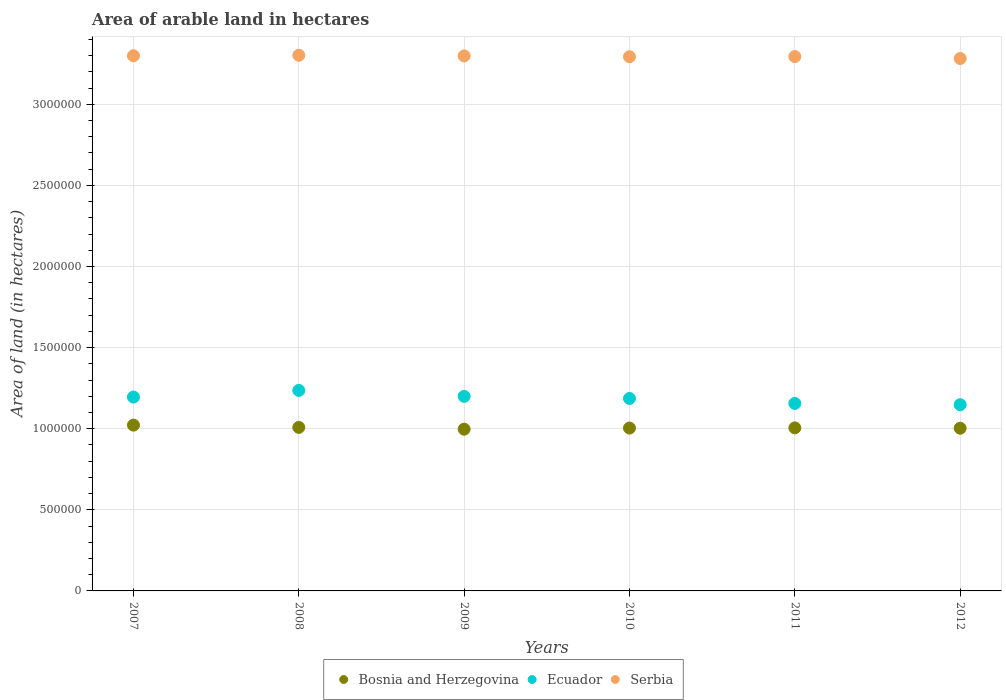What is the total arable land in Bosnia and Herzegovina in 2012?
Keep it short and to the point. 1.00e+06. Across all years, what is the maximum total arable land in Ecuador?
Provide a succinct answer. 1.24e+06. Across all years, what is the minimum total arable land in Bosnia and Herzegovina?
Provide a succinct answer. 9.97e+05. What is the total total arable land in Serbia in the graph?
Your answer should be very brief. 1.98e+07. What is the difference between the total arable land in Serbia in 2009 and that in 2011?
Offer a very short reply. 4000. What is the difference between the total arable land in Serbia in 2010 and the total arable land in Ecuador in 2008?
Give a very brief answer. 2.06e+06. What is the average total arable land in Serbia per year?
Offer a very short reply. 3.29e+06. In the year 2011, what is the difference between the total arable land in Ecuador and total arable land in Serbia?
Give a very brief answer. -2.14e+06. What is the ratio of the total arable land in Ecuador in 2008 to that in 2011?
Your response must be concise. 1.07. Is the difference between the total arable land in Ecuador in 2007 and 2012 greater than the difference between the total arable land in Serbia in 2007 and 2012?
Provide a short and direct response. Yes. What is the difference between the highest and the second highest total arable land in Bosnia and Herzegovina?
Provide a succinct answer. 1.40e+04. Is it the case that in every year, the sum of the total arable land in Ecuador and total arable land in Serbia  is greater than the total arable land in Bosnia and Herzegovina?
Offer a terse response. Yes. Is the total arable land in Ecuador strictly greater than the total arable land in Bosnia and Herzegovina over the years?
Make the answer very short. Yes. Is the total arable land in Serbia strictly less than the total arable land in Bosnia and Herzegovina over the years?
Your answer should be compact. No. How many dotlines are there?
Ensure brevity in your answer.  3. Where does the legend appear in the graph?
Offer a very short reply. Bottom center. How are the legend labels stacked?
Provide a short and direct response. Horizontal. What is the title of the graph?
Give a very brief answer. Area of arable land in hectares. Does "Cyprus" appear as one of the legend labels in the graph?
Provide a succinct answer. No. What is the label or title of the X-axis?
Offer a very short reply. Years. What is the label or title of the Y-axis?
Ensure brevity in your answer.  Area of land (in hectares). What is the Area of land (in hectares) in Bosnia and Herzegovina in 2007?
Your response must be concise. 1.02e+06. What is the Area of land (in hectares) of Ecuador in 2007?
Give a very brief answer. 1.20e+06. What is the Area of land (in hectares) of Serbia in 2007?
Provide a short and direct response. 3.30e+06. What is the Area of land (in hectares) in Bosnia and Herzegovina in 2008?
Offer a terse response. 1.01e+06. What is the Area of land (in hectares) of Ecuador in 2008?
Your response must be concise. 1.24e+06. What is the Area of land (in hectares) of Serbia in 2008?
Your answer should be very brief. 3.30e+06. What is the Area of land (in hectares) of Bosnia and Herzegovina in 2009?
Your answer should be compact. 9.97e+05. What is the Area of land (in hectares) in Ecuador in 2009?
Your answer should be compact. 1.20e+06. What is the Area of land (in hectares) of Serbia in 2009?
Keep it short and to the point. 3.30e+06. What is the Area of land (in hectares) of Bosnia and Herzegovina in 2010?
Provide a succinct answer. 1.00e+06. What is the Area of land (in hectares) of Ecuador in 2010?
Your answer should be very brief. 1.19e+06. What is the Area of land (in hectares) of Serbia in 2010?
Provide a short and direct response. 3.29e+06. What is the Area of land (in hectares) in Bosnia and Herzegovina in 2011?
Provide a short and direct response. 1.00e+06. What is the Area of land (in hectares) of Ecuador in 2011?
Offer a terse response. 1.16e+06. What is the Area of land (in hectares) in Serbia in 2011?
Give a very brief answer. 3.29e+06. What is the Area of land (in hectares) in Bosnia and Herzegovina in 2012?
Give a very brief answer. 1.00e+06. What is the Area of land (in hectares) in Ecuador in 2012?
Offer a very short reply. 1.15e+06. What is the Area of land (in hectares) in Serbia in 2012?
Offer a very short reply. 3.28e+06. Across all years, what is the maximum Area of land (in hectares) in Bosnia and Herzegovina?
Give a very brief answer. 1.02e+06. Across all years, what is the maximum Area of land (in hectares) in Ecuador?
Offer a terse response. 1.24e+06. Across all years, what is the maximum Area of land (in hectares) in Serbia?
Provide a succinct answer. 3.30e+06. Across all years, what is the minimum Area of land (in hectares) in Bosnia and Herzegovina?
Ensure brevity in your answer.  9.97e+05. Across all years, what is the minimum Area of land (in hectares) in Ecuador?
Offer a terse response. 1.15e+06. Across all years, what is the minimum Area of land (in hectares) in Serbia?
Your response must be concise. 3.28e+06. What is the total Area of land (in hectares) in Bosnia and Herzegovina in the graph?
Ensure brevity in your answer.  6.04e+06. What is the total Area of land (in hectares) of Ecuador in the graph?
Provide a succinct answer. 7.12e+06. What is the total Area of land (in hectares) in Serbia in the graph?
Your response must be concise. 1.98e+07. What is the difference between the Area of land (in hectares) in Bosnia and Herzegovina in 2007 and that in 2008?
Offer a very short reply. 1.40e+04. What is the difference between the Area of land (in hectares) of Ecuador in 2007 and that in 2008?
Offer a very short reply. -4.10e+04. What is the difference between the Area of land (in hectares) in Serbia in 2007 and that in 2008?
Offer a very short reply. -3000. What is the difference between the Area of land (in hectares) of Bosnia and Herzegovina in 2007 and that in 2009?
Offer a terse response. 2.50e+04. What is the difference between the Area of land (in hectares) of Ecuador in 2007 and that in 2009?
Your answer should be very brief. -4400. What is the difference between the Area of land (in hectares) of Serbia in 2007 and that in 2009?
Your response must be concise. 1000. What is the difference between the Area of land (in hectares) of Bosnia and Herzegovina in 2007 and that in 2010?
Your response must be concise. 1.80e+04. What is the difference between the Area of land (in hectares) of Ecuador in 2007 and that in 2010?
Your answer should be very brief. 8600. What is the difference between the Area of land (in hectares) in Serbia in 2007 and that in 2010?
Give a very brief answer. 6000. What is the difference between the Area of land (in hectares) of Bosnia and Herzegovina in 2007 and that in 2011?
Ensure brevity in your answer.  1.70e+04. What is the difference between the Area of land (in hectares) in Ecuador in 2007 and that in 2011?
Offer a very short reply. 3.93e+04. What is the difference between the Area of land (in hectares) of Bosnia and Herzegovina in 2007 and that in 2012?
Your response must be concise. 1.90e+04. What is the difference between the Area of land (in hectares) of Ecuador in 2007 and that in 2012?
Ensure brevity in your answer.  4.71e+04. What is the difference between the Area of land (in hectares) of Serbia in 2007 and that in 2012?
Provide a short and direct response. 1.70e+04. What is the difference between the Area of land (in hectares) of Bosnia and Herzegovina in 2008 and that in 2009?
Offer a terse response. 1.10e+04. What is the difference between the Area of land (in hectares) in Ecuador in 2008 and that in 2009?
Your answer should be very brief. 3.66e+04. What is the difference between the Area of land (in hectares) of Serbia in 2008 and that in 2009?
Offer a very short reply. 4000. What is the difference between the Area of land (in hectares) in Bosnia and Herzegovina in 2008 and that in 2010?
Your answer should be compact. 4000. What is the difference between the Area of land (in hectares) in Ecuador in 2008 and that in 2010?
Offer a very short reply. 4.96e+04. What is the difference between the Area of land (in hectares) of Serbia in 2008 and that in 2010?
Keep it short and to the point. 9000. What is the difference between the Area of land (in hectares) in Bosnia and Herzegovina in 2008 and that in 2011?
Provide a succinct answer. 3000. What is the difference between the Area of land (in hectares) in Ecuador in 2008 and that in 2011?
Offer a terse response. 8.03e+04. What is the difference between the Area of land (in hectares) in Serbia in 2008 and that in 2011?
Provide a succinct answer. 8000. What is the difference between the Area of land (in hectares) of Bosnia and Herzegovina in 2008 and that in 2012?
Your response must be concise. 5000. What is the difference between the Area of land (in hectares) in Ecuador in 2008 and that in 2012?
Keep it short and to the point. 8.81e+04. What is the difference between the Area of land (in hectares) of Bosnia and Herzegovina in 2009 and that in 2010?
Your response must be concise. -7000. What is the difference between the Area of land (in hectares) in Ecuador in 2009 and that in 2010?
Your response must be concise. 1.30e+04. What is the difference between the Area of land (in hectares) in Bosnia and Herzegovina in 2009 and that in 2011?
Make the answer very short. -8000. What is the difference between the Area of land (in hectares) of Ecuador in 2009 and that in 2011?
Make the answer very short. 4.37e+04. What is the difference between the Area of land (in hectares) of Serbia in 2009 and that in 2011?
Provide a succinct answer. 4000. What is the difference between the Area of land (in hectares) of Bosnia and Herzegovina in 2009 and that in 2012?
Give a very brief answer. -6000. What is the difference between the Area of land (in hectares) of Ecuador in 2009 and that in 2012?
Offer a very short reply. 5.15e+04. What is the difference between the Area of land (in hectares) in Serbia in 2009 and that in 2012?
Keep it short and to the point. 1.60e+04. What is the difference between the Area of land (in hectares) in Bosnia and Herzegovina in 2010 and that in 2011?
Provide a short and direct response. -1000. What is the difference between the Area of land (in hectares) of Ecuador in 2010 and that in 2011?
Your answer should be very brief. 3.07e+04. What is the difference between the Area of land (in hectares) of Serbia in 2010 and that in 2011?
Your answer should be compact. -1000. What is the difference between the Area of land (in hectares) of Bosnia and Herzegovina in 2010 and that in 2012?
Your answer should be compact. 1000. What is the difference between the Area of land (in hectares) of Ecuador in 2010 and that in 2012?
Ensure brevity in your answer.  3.85e+04. What is the difference between the Area of land (in hectares) in Serbia in 2010 and that in 2012?
Provide a succinct answer. 1.10e+04. What is the difference between the Area of land (in hectares) of Bosnia and Herzegovina in 2011 and that in 2012?
Keep it short and to the point. 2000. What is the difference between the Area of land (in hectares) of Ecuador in 2011 and that in 2012?
Keep it short and to the point. 7800. What is the difference between the Area of land (in hectares) of Serbia in 2011 and that in 2012?
Make the answer very short. 1.20e+04. What is the difference between the Area of land (in hectares) in Bosnia and Herzegovina in 2007 and the Area of land (in hectares) in Ecuador in 2008?
Ensure brevity in your answer.  -2.14e+05. What is the difference between the Area of land (in hectares) of Bosnia and Herzegovina in 2007 and the Area of land (in hectares) of Serbia in 2008?
Your answer should be compact. -2.28e+06. What is the difference between the Area of land (in hectares) in Ecuador in 2007 and the Area of land (in hectares) in Serbia in 2008?
Your answer should be compact. -2.11e+06. What is the difference between the Area of land (in hectares) of Bosnia and Herzegovina in 2007 and the Area of land (in hectares) of Ecuador in 2009?
Offer a very short reply. -1.77e+05. What is the difference between the Area of land (in hectares) of Bosnia and Herzegovina in 2007 and the Area of land (in hectares) of Serbia in 2009?
Your answer should be compact. -2.28e+06. What is the difference between the Area of land (in hectares) of Ecuador in 2007 and the Area of land (in hectares) of Serbia in 2009?
Offer a terse response. -2.10e+06. What is the difference between the Area of land (in hectares) of Bosnia and Herzegovina in 2007 and the Area of land (in hectares) of Ecuador in 2010?
Offer a very short reply. -1.64e+05. What is the difference between the Area of land (in hectares) in Bosnia and Herzegovina in 2007 and the Area of land (in hectares) in Serbia in 2010?
Your answer should be compact. -2.27e+06. What is the difference between the Area of land (in hectares) of Ecuador in 2007 and the Area of land (in hectares) of Serbia in 2010?
Your answer should be very brief. -2.10e+06. What is the difference between the Area of land (in hectares) of Bosnia and Herzegovina in 2007 and the Area of land (in hectares) of Ecuador in 2011?
Give a very brief answer. -1.34e+05. What is the difference between the Area of land (in hectares) in Bosnia and Herzegovina in 2007 and the Area of land (in hectares) in Serbia in 2011?
Provide a short and direct response. -2.27e+06. What is the difference between the Area of land (in hectares) in Ecuador in 2007 and the Area of land (in hectares) in Serbia in 2011?
Give a very brief answer. -2.10e+06. What is the difference between the Area of land (in hectares) of Bosnia and Herzegovina in 2007 and the Area of land (in hectares) of Ecuador in 2012?
Your answer should be very brief. -1.26e+05. What is the difference between the Area of land (in hectares) of Bosnia and Herzegovina in 2007 and the Area of land (in hectares) of Serbia in 2012?
Make the answer very short. -2.26e+06. What is the difference between the Area of land (in hectares) of Ecuador in 2007 and the Area of land (in hectares) of Serbia in 2012?
Offer a terse response. -2.09e+06. What is the difference between the Area of land (in hectares) in Bosnia and Herzegovina in 2008 and the Area of land (in hectares) in Ecuador in 2009?
Make the answer very short. -1.91e+05. What is the difference between the Area of land (in hectares) of Bosnia and Herzegovina in 2008 and the Area of land (in hectares) of Serbia in 2009?
Give a very brief answer. -2.29e+06. What is the difference between the Area of land (in hectares) of Ecuador in 2008 and the Area of land (in hectares) of Serbia in 2009?
Offer a terse response. -2.06e+06. What is the difference between the Area of land (in hectares) of Bosnia and Herzegovina in 2008 and the Area of land (in hectares) of Ecuador in 2010?
Your response must be concise. -1.78e+05. What is the difference between the Area of land (in hectares) in Bosnia and Herzegovina in 2008 and the Area of land (in hectares) in Serbia in 2010?
Provide a succinct answer. -2.28e+06. What is the difference between the Area of land (in hectares) of Ecuador in 2008 and the Area of land (in hectares) of Serbia in 2010?
Your answer should be very brief. -2.06e+06. What is the difference between the Area of land (in hectares) in Bosnia and Herzegovina in 2008 and the Area of land (in hectares) in Ecuador in 2011?
Keep it short and to the point. -1.48e+05. What is the difference between the Area of land (in hectares) of Bosnia and Herzegovina in 2008 and the Area of land (in hectares) of Serbia in 2011?
Your answer should be compact. -2.29e+06. What is the difference between the Area of land (in hectares) of Ecuador in 2008 and the Area of land (in hectares) of Serbia in 2011?
Your response must be concise. -2.06e+06. What is the difference between the Area of land (in hectares) of Bosnia and Herzegovina in 2008 and the Area of land (in hectares) of Ecuador in 2012?
Give a very brief answer. -1.40e+05. What is the difference between the Area of land (in hectares) in Bosnia and Herzegovina in 2008 and the Area of land (in hectares) in Serbia in 2012?
Your response must be concise. -2.27e+06. What is the difference between the Area of land (in hectares) of Ecuador in 2008 and the Area of land (in hectares) of Serbia in 2012?
Make the answer very short. -2.05e+06. What is the difference between the Area of land (in hectares) in Bosnia and Herzegovina in 2009 and the Area of land (in hectares) in Ecuador in 2010?
Your answer should be compact. -1.89e+05. What is the difference between the Area of land (in hectares) in Bosnia and Herzegovina in 2009 and the Area of land (in hectares) in Serbia in 2010?
Your response must be concise. -2.30e+06. What is the difference between the Area of land (in hectares) in Ecuador in 2009 and the Area of land (in hectares) in Serbia in 2010?
Keep it short and to the point. -2.09e+06. What is the difference between the Area of land (in hectares) of Bosnia and Herzegovina in 2009 and the Area of land (in hectares) of Ecuador in 2011?
Give a very brief answer. -1.59e+05. What is the difference between the Area of land (in hectares) in Bosnia and Herzegovina in 2009 and the Area of land (in hectares) in Serbia in 2011?
Ensure brevity in your answer.  -2.30e+06. What is the difference between the Area of land (in hectares) in Ecuador in 2009 and the Area of land (in hectares) in Serbia in 2011?
Offer a terse response. -2.09e+06. What is the difference between the Area of land (in hectares) of Bosnia and Herzegovina in 2009 and the Area of land (in hectares) of Ecuador in 2012?
Your response must be concise. -1.51e+05. What is the difference between the Area of land (in hectares) of Bosnia and Herzegovina in 2009 and the Area of land (in hectares) of Serbia in 2012?
Your response must be concise. -2.28e+06. What is the difference between the Area of land (in hectares) in Ecuador in 2009 and the Area of land (in hectares) in Serbia in 2012?
Provide a short and direct response. -2.08e+06. What is the difference between the Area of land (in hectares) of Bosnia and Herzegovina in 2010 and the Area of land (in hectares) of Ecuador in 2011?
Give a very brief answer. -1.52e+05. What is the difference between the Area of land (in hectares) of Bosnia and Herzegovina in 2010 and the Area of land (in hectares) of Serbia in 2011?
Offer a very short reply. -2.29e+06. What is the difference between the Area of land (in hectares) of Ecuador in 2010 and the Area of land (in hectares) of Serbia in 2011?
Your answer should be very brief. -2.11e+06. What is the difference between the Area of land (in hectares) of Bosnia and Herzegovina in 2010 and the Area of land (in hectares) of Ecuador in 2012?
Offer a terse response. -1.44e+05. What is the difference between the Area of land (in hectares) of Bosnia and Herzegovina in 2010 and the Area of land (in hectares) of Serbia in 2012?
Provide a short and direct response. -2.28e+06. What is the difference between the Area of land (in hectares) in Ecuador in 2010 and the Area of land (in hectares) in Serbia in 2012?
Keep it short and to the point. -2.10e+06. What is the difference between the Area of land (in hectares) of Bosnia and Herzegovina in 2011 and the Area of land (in hectares) of Ecuador in 2012?
Offer a terse response. -1.43e+05. What is the difference between the Area of land (in hectares) in Bosnia and Herzegovina in 2011 and the Area of land (in hectares) in Serbia in 2012?
Your response must be concise. -2.28e+06. What is the difference between the Area of land (in hectares) of Ecuador in 2011 and the Area of land (in hectares) of Serbia in 2012?
Your answer should be very brief. -2.13e+06. What is the average Area of land (in hectares) of Bosnia and Herzegovina per year?
Your answer should be very brief. 1.01e+06. What is the average Area of land (in hectares) in Ecuador per year?
Your answer should be very brief. 1.19e+06. What is the average Area of land (in hectares) in Serbia per year?
Provide a short and direct response. 3.29e+06. In the year 2007, what is the difference between the Area of land (in hectares) of Bosnia and Herzegovina and Area of land (in hectares) of Ecuador?
Your answer should be compact. -1.73e+05. In the year 2007, what is the difference between the Area of land (in hectares) of Bosnia and Herzegovina and Area of land (in hectares) of Serbia?
Provide a short and direct response. -2.28e+06. In the year 2007, what is the difference between the Area of land (in hectares) in Ecuador and Area of land (in hectares) in Serbia?
Your response must be concise. -2.10e+06. In the year 2008, what is the difference between the Area of land (in hectares) in Bosnia and Herzegovina and Area of land (in hectares) in Ecuador?
Make the answer very short. -2.28e+05. In the year 2008, what is the difference between the Area of land (in hectares) in Bosnia and Herzegovina and Area of land (in hectares) in Serbia?
Your response must be concise. -2.29e+06. In the year 2008, what is the difference between the Area of land (in hectares) of Ecuador and Area of land (in hectares) of Serbia?
Make the answer very short. -2.07e+06. In the year 2009, what is the difference between the Area of land (in hectares) in Bosnia and Herzegovina and Area of land (in hectares) in Ecuador?
Give a very brief answer. -2.02e+05. In the year 2009, what is the difference between the Area of land (in hectares) of Bosnia and Herzegovina and Area of land (in hectares) of Serbia?
Give a very brief answer. -2.30e+06. In the year 2009, what is the difference between the Area of land (in hectares) of Ecuador and Area of land (in hectares) of Serbia?
Your answer should be compact. -2.10e+06. In the year 2010, what is the difference between the Area of land (in hectares) of Bosnia and Herzegovina and Area of land (in hectares) of Ecuador?
Ensure brevity in your answer.  -1.82e+05. In the year 2010, what is the difference between the Area of land (in hectares) of Bosnia and Herzegovina and Area of land (in hectares) of Serbia?
Provide a succinct answer. -2.29e+06. In the year 2010, what is the difference between the Area of land (in hectares) in Ecuador and Area of land (in hectares) in Serbia?
Provide a short and direct response. -2.11e+06. In the year 2011, what is the difference between the Area of land (in hectares) of Bosnia and Herzegovina and Area of land (in hectares) of Ecuador?
Your response must be concise. -1.51e+05. In the year 2011, what is the difference between the Area of land (in hectares) of Bosnia and Herzegovina and Area of land (in hectares) of Serbia?
Ensure brevity in your answer.  -2.29e+06. In the year 2011, what is the difference between the Area of land (in hectares) of Ecuador and Area of land (in hectares) of Serbia?
Keep it short and to the point. -2.14e+06. In the year 2012, what is the difference between the Area of land (in hectares) of Bosnia and Herzegovina and Area of land (in hectares) of Ecuador?
Keep it short and to the point. -1.45e+05. In the year 2012, what is the difference between the Area of land (in hectares) in Bosnia and Herzegovina and Area of land (in hectares) in Serbia?
Keep it short and to the point. -2.28e+06. In the year 2012, what is the difference between the Area of land (in hectares) of Ecuador and Area of land (in hectares) of Serbia?
Provide a succinct answer. -2.13e+06. What is the ratio of the Area of land (in hectares) in Bosnia and Herzegovina in 2007 to that in 2008?
Give a very brief answer. 1.01. What is the ratio of the Area of land (in hectares) in Ecuador in 2007 to that in 2008?
Give a very brief answer. 0.97. What is the ratio of the Area of land (in hectares) of Bosnia and Herzegovina in 2007 to that in 2009?
Ensure brevity in your answer.  1.03. What is the ratio of the Area of land (in hectares) in Ecuador in 2007 to that in 2009?
Ensure brevity in your answer.  1. What is the ratio of the Area of land (in hectares) of Bosnia and Herzegovina in 2007 to that in 2010?
Provide a short and direct response. 1.02. What is the ratio of the Area of land (in hectares) of Ecuador in 2007 to that in 2010?
Your answer should be compact. 1.01. What is the ratio of the Area of land (in hectares) of Bosnia and Herzegovina in 2007 to that in 2011?
Keep it short and to the point. 1.02. What is the ratio of the Area of land (in hectares) in Ecuador in 2007 to that in 2011?
Your answer should be very brief. 1.03. What is the ratio of the Area of land (in hectares) in Bosnia and Herzegovina in 2007 to that in 2012?
Your response must be concise. 1.02. What is the ratio of the Area of land (in hectares) of Ecuador in 2007 to that in 2012?
Ensure brevity in your answer.  1.04. What is the ratio of the Area of land (in hectares) of Bosnia and Herzegovina in 2008 to that in 2009?
Offer a very short reply. 1.01. What is the ratio of the Area of land (in hectares) of Ecuador in 2008 to that in 2009?
Keep it short and to the point. 1.03. What is the ratio of the Area of land (in hectares) of Bosnia and Herzegovina in 2008 to that in 2010?
Make the answer very short. 1. What is the ratio of the Area of land (in hectares) of Ecuador in 2008 to that in 2010?
Make the answer very short. 1.04. What is the ratio of the Area of land (in hectares) in Ecuador in 2008 to that in 2011?
Your answer should be compact. 1.07. What is the ratio of the Area of land (in hectares) in Serbia in 2008 to that in 2011?
Your response must be concise. 1. What is the ratio of the Area of land (in hectares) in Ecuador in 2008 to that in 2012?
Your answer should be compact. 1.08. What is the ratio of the Area of land (in hectares) in Ecuador in 2009 to that in 2010?
Keep it short and to the point. 1.01. What is the ratio of the Area of land (in hectares) in Serbia in 2009 to that in 2010?
Make the answer very short. 1. What is the ratio of the Area of land (in hectares) in Ecuador in 2009 to that in 2011?
Provide a short and direct response. 1.04. What is the ratio of the Area of land (in hectares) in Serbia in 2009 to that in 2011?
Make the answer very short. 1. What is the ratio of the Area of land (in hectares) of Ecuador in 2009 to that in 2012?
Offer a terse response. 1.04. What is the ratio of the Area of land (in hectares) in Ecuador in 2010 to that in 2011?
Your answer should be compact. 1.03. What is the ratio of the Area of land (in hectares) of Ecuador in 2010 to that in 2012?
Make the answer very short. 1.03. What is the ratio of the Area of land (in hectares) of Ecuador in 2011 to that in 2012?
Your response must be concise. 1.01. What is the ratio of the Area of land (in hectares) of Serbia in 2011 to that in 2012?
Provide a short and direct response. 1. What is the difference between the highest and the second highest Area of land (in hectares) in Bosnia and Herzegovina?
Offer a very short reply. 1.40e+04. What is the difference between the highest and the second highest Area of land (in hectares) of Ecuador?
Ensure brevity in your answer.  3.66e+04. What is the difference between the highest and the second highest Area of land (in hectares) of Serbia?
Provide a succinct answer. 3000. What is the difference between the highest and the lowest Area of land (in hectares) in Bosnia and Herzegovina?
Make the answer very short. 2.50e+04. What is the difference between the highest and the lowest Area of land (in hectares) of Ecuador?
Provide a succinct answer. 8.81e+04. 